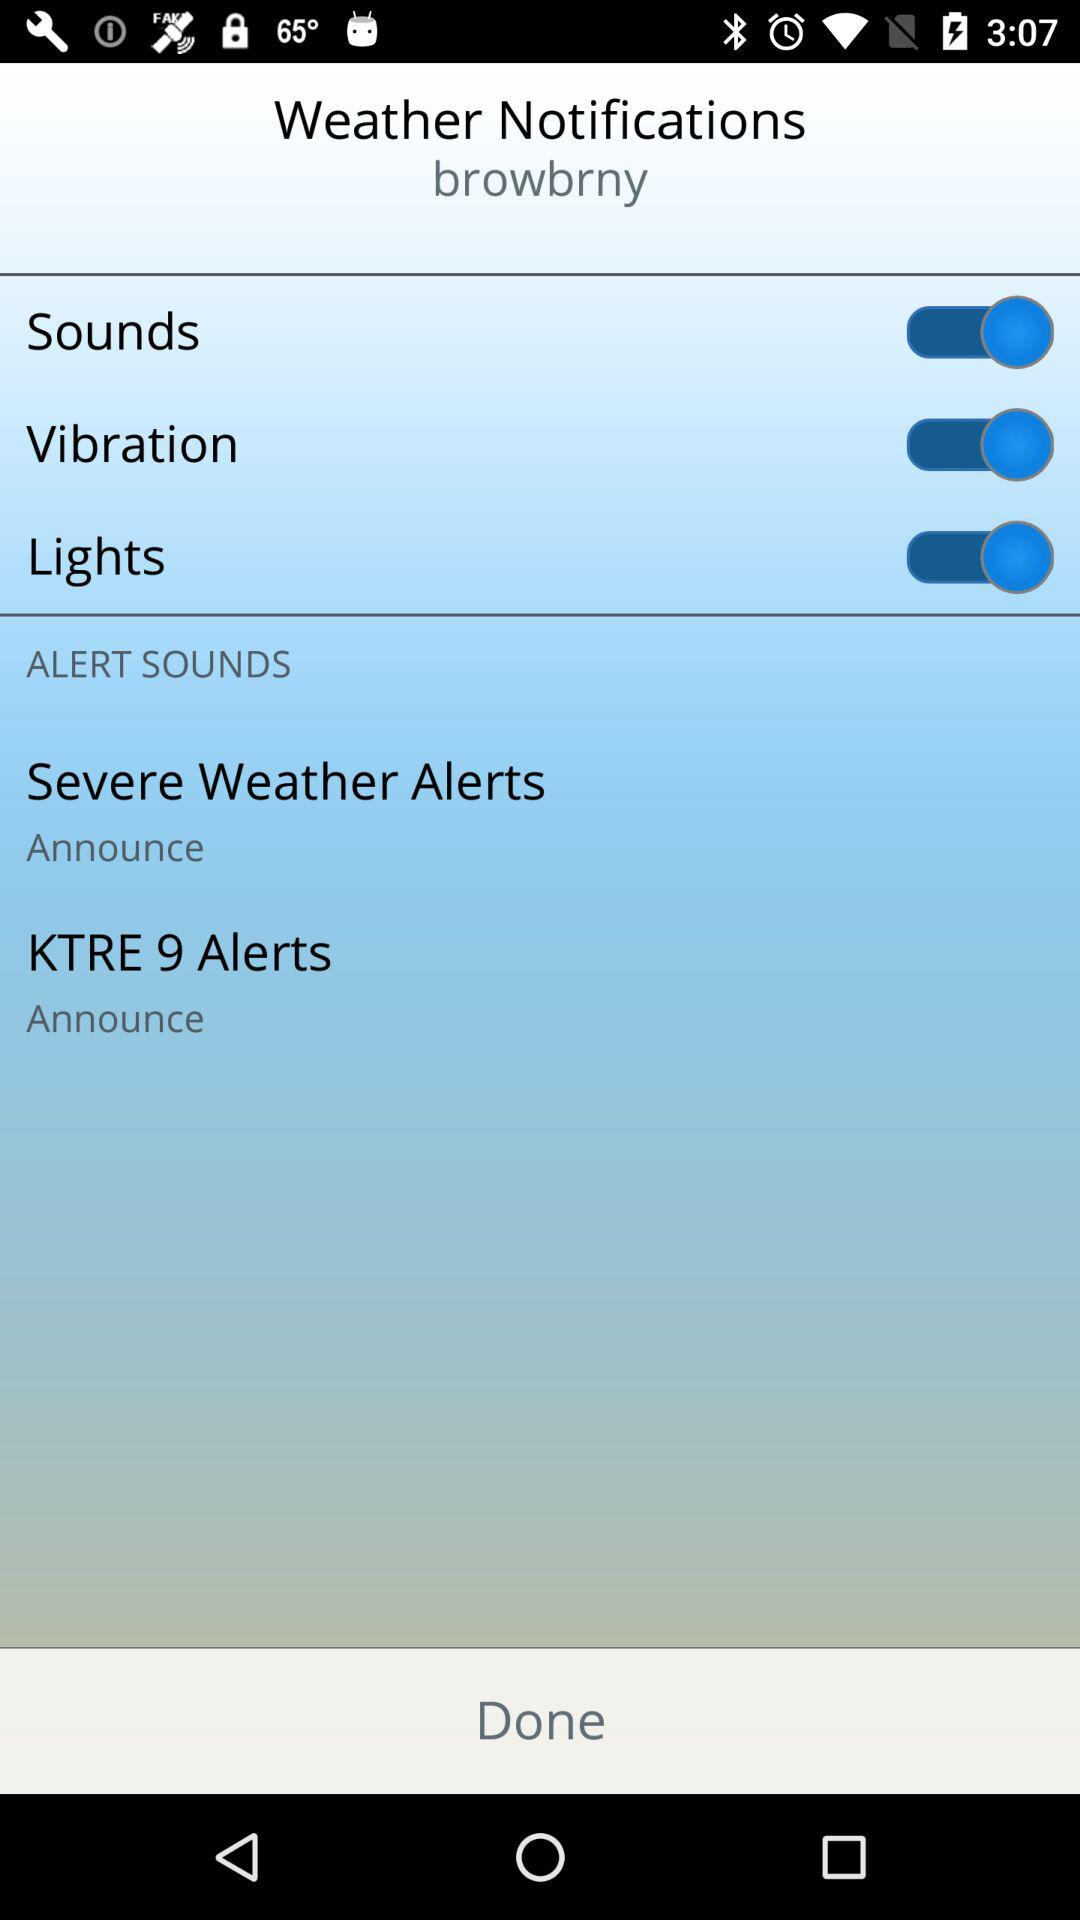What is the status of "Vibration"? The status is "on". 